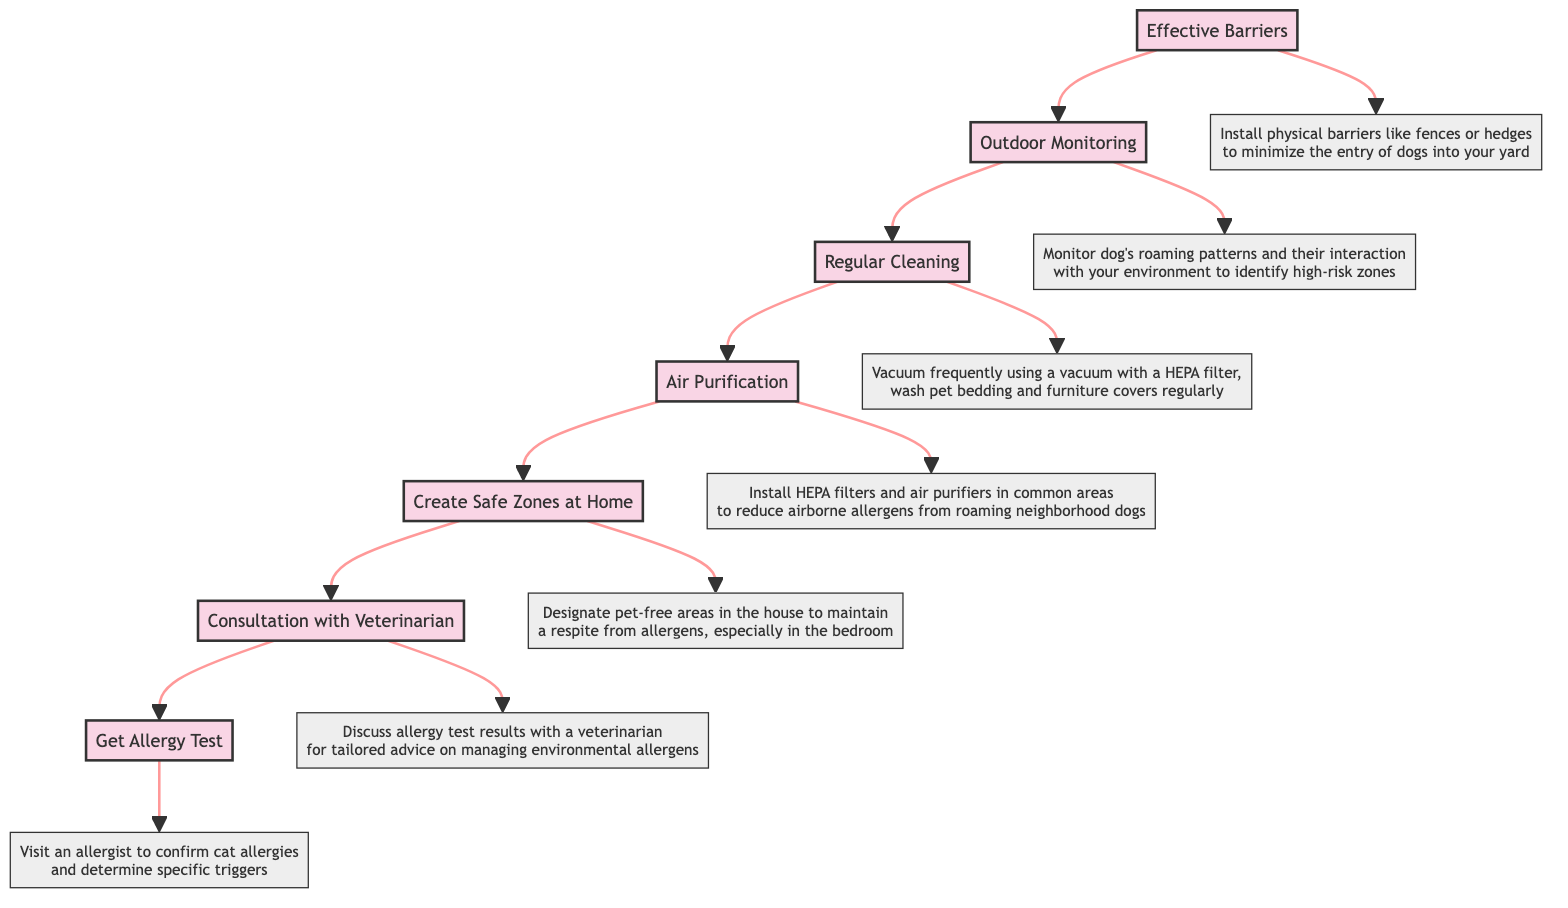What is the first stage in the flow chart? The first stage in the flow chart is at the top and represents the starting point of managing cat allergies. It is labeled "Get Allergy Test".
Answer: Get Allergy Test How many stages are there in total? By counting the stages listed in the flow chart, we can see that there are a total of seven distinct stages.
Answer: Seven What follows the "Effective Barriers" stage? In the flow chart, the "Effective Barriers" stage points upwards to the "Outdoor Monitoring" stage, indicating that it is the next step in the process.
Answer: Outdoor Monitoring Which stage involves consultation with a veterinarian? The second stage in the flow chart is where you discuss the allergy test results; this stage is labeled "Consultation with Veterinarian".
Answer: Consultation with Veterinarian How does "Air Purification" relate to "Regular Cleaning"? "Air Purification" is a stage that leads directly to "Regular Cleaning" in the flow chart, indicating that both are strategies used to manage allergens but "Air Purification" comes before "Regular Cleaning".
Answer: It precedes it What is the purpose of creating safe zones at home? The purpose of this stage is stated to maintain a respite from allergens, particularly in sensitive areas like the bedroom. This is reinforced by the description connected to "Create Safe Zones at Home".
Answer: Maintain respite from allergens What should be installed to help reduce airborne allergens? The stage labeled "Air Purification" specifies the installation of HEPA filters and air purifiers for reduction of airborne allergens from the environment.
Answer: HEPA filters and air purifiers What two stages deal with cleaning activities? The stages concerned with cleaning activities are "Regular Cleaning" and "Create Safe Zones at Home", which both emphasize managing the environment to control allergens. The flow indicates these are related to cleanliness.
Answer: Regular Cleaning and Create Safe Zones at Home Which stage directly leads to a discussion about allergy test results? The stage that directly leads to a discussion regarding the allergy test results is "Consultation with Veterinarian", which comes just after "Get Allergy Test".
Answer: Consultation with Veterinarian 